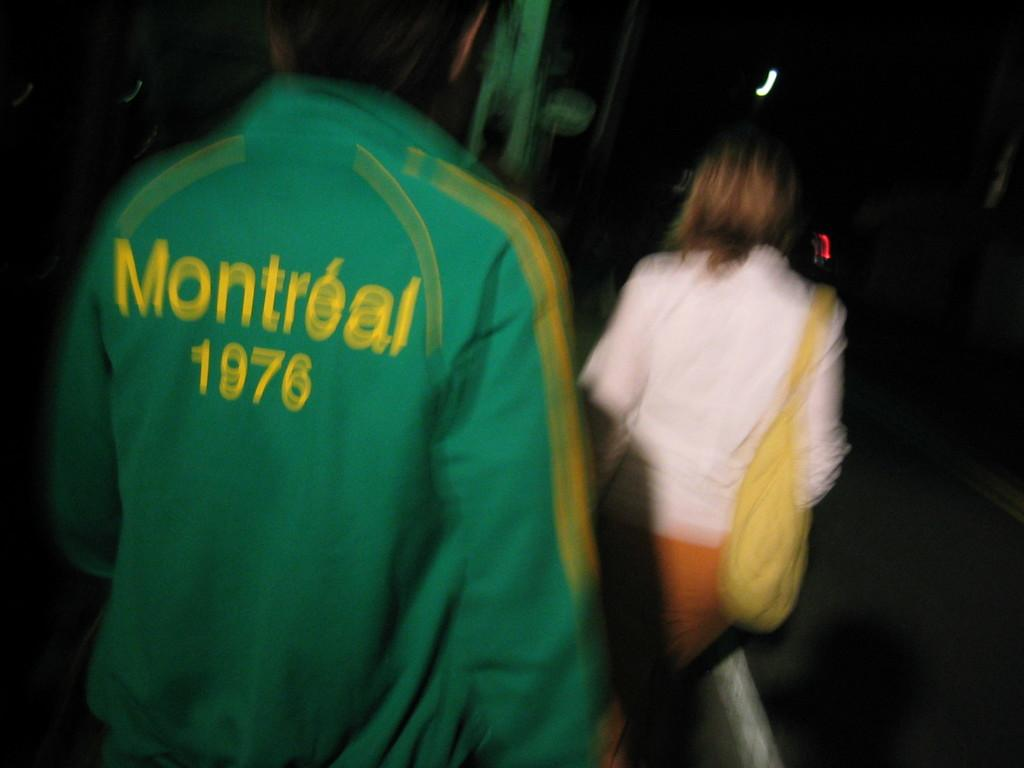<image>
Share a concise interpretation of the image provided. Man wearing a green jacket that says Montreal on it. 